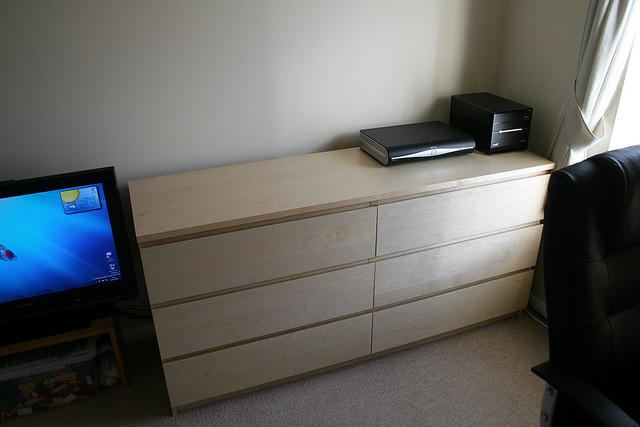What is on the computer screen?
Short answer required. Desktop. How many drawers in the dresser?
Be succinct. 6. Does the furniture appear to be a contemporary assembled piece or hundred year old family heirloom?
Answer briefly. Contemporary. Is the tv on?
Answer briefly. Yes. Is that a bed?
Give a very brief answer. No. 